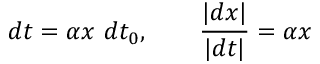Convert formula to latex. <formula><loc_0><loc_0><loc_500><loc_500>d t = \alpha x \ d t _ { 0 } , \quad { \frac { | d x | } { | d t | } } = \alpha x</formula> 